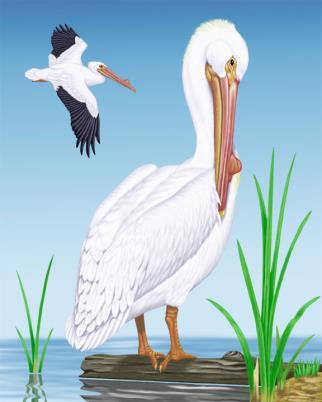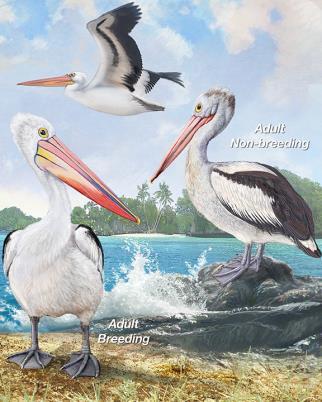The first image is the image on the left, the second image is the image on the right. For the images shown, is this caption "An image shows exactly two pelicans, including one that is in flight." true? Answer yes or no. Yes. 